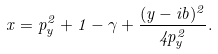<formula> <loc_0><loc_0><loc_500><loc_500>x = p ^ { 2 } _ { y } + 1 - \gamma + \frac { ( y - i b ) ^ { 2 } } { 4 p ^ { 2 } _ { y } } .</formula> 